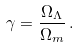<formula> <loc_0><loc_0><loc_500><loc_500>\gamma = \frac { \Omega _ { \Lambda } } { \Omega _ { m } } \, .</formula> 